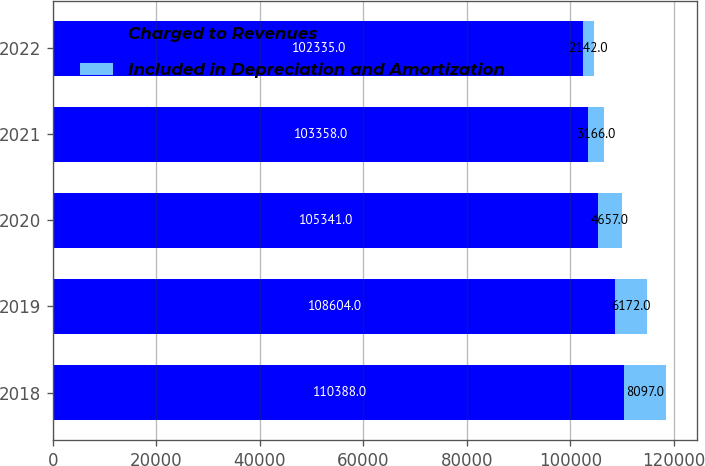Convert chart. <chart><loc_0><loc_0><loc_500><loc_500><stacked_bar_chart><ecel><fcel>2018<fcel>2019<fcel>2020<fcel>2021<fcel>2022<nl><fcel>Charged to Revenues<fcel>110388<fcel>108604<fcel>105341<fcel>103358<fcel>102335<nl><fcel>Included in Depreciation and Amortization<fcel>8097<fcel>6172<fcel>4657<fcel>3166<fcel>2142<nl></chart> 